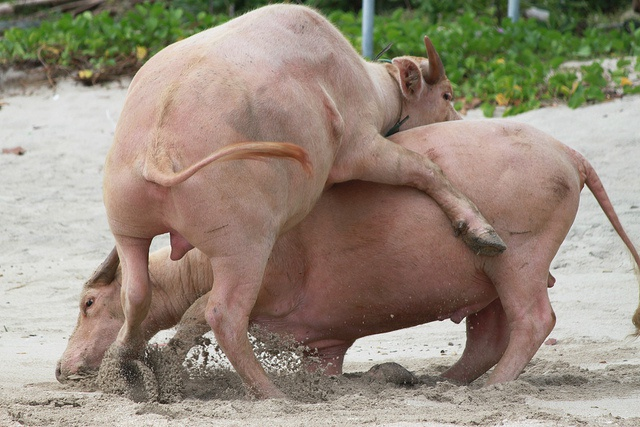Describe the objects in this image and their specific colors. I can see cow in darkgreen, gray, darkgray, and tan tones, sheep in darkgreen, gray, darkgray, and tan tones, and cow in darkgreen, gray, brown, and maroon tones in this image. 